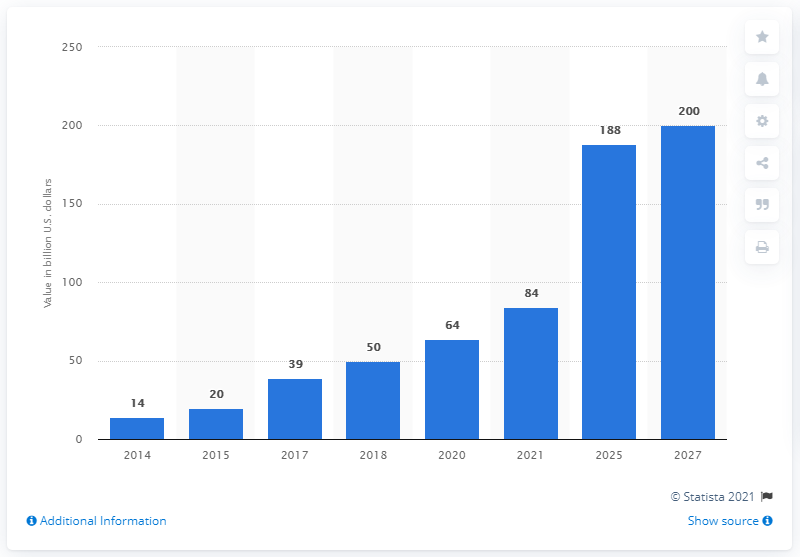Give some essential details in this illustration. In 2018, the market value of the e-commerce industry in India was approximately Rs. 50,000 crore. The estimated market value of the e-commerce industry in India by 2027 is expected to reach 200 billion USD. 